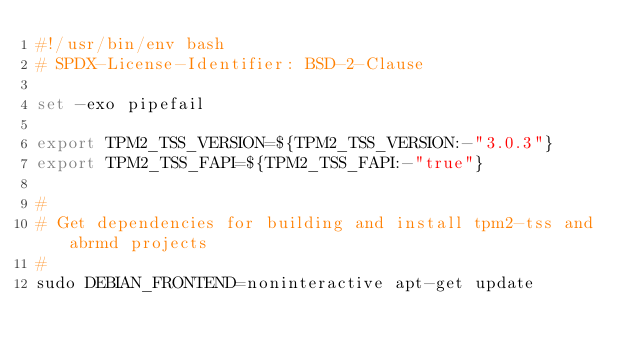<code> <loc_0><loc_0><loc_500><loc_500><_Bash_>#!/usr/bin/env bash
# SPDX-License-Identifier: BSD-2-Clause

set -exo pipefail

export TPM2_TSS_VERSION=${TPM2_TSS_VERSION:-"3.0.3"}
export TPM2_TSS_FAPI=${TPM2_TSS_FAPI:-"true"}

#
# Get dependencies for building and install tpm2-tss and abrmd projects
#
sudo DEBIAN_FRONTEND=noninteractive apt-get update</code> 